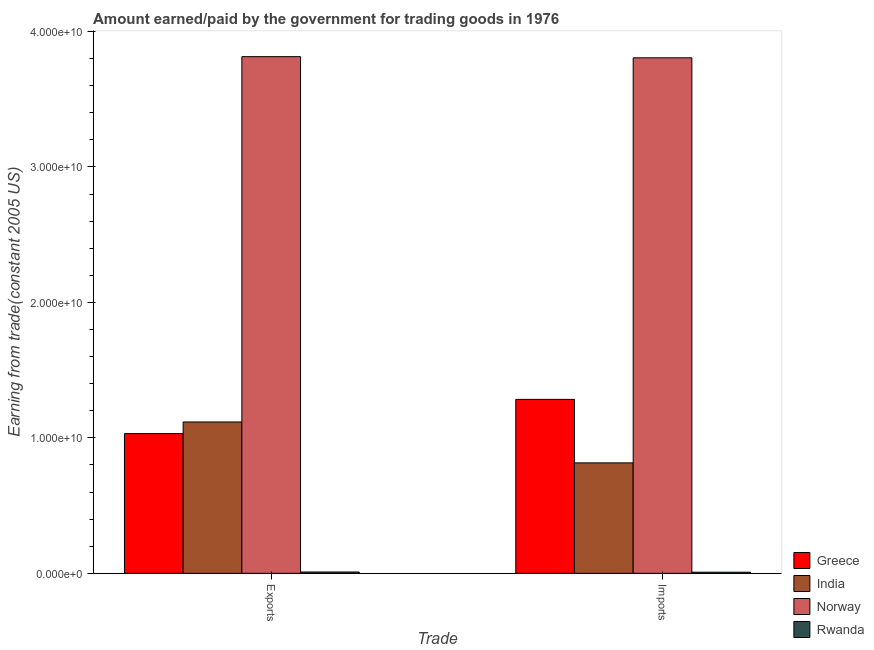How many different coloured bars are there?
Keep it short and to the point. 4. Are the number of bars per tick equal to the number of legend labels?
Provide a succinct answer. Yes. What is the label of the 2nd group of bars from the left?
Offer a very short reply. Imports. What is the amount paid for imports in Norway?
Keep it short and to the point. 3.81e+1. Across all countries, what is the maximum amount earned from exports?
Give a very brief answer. 3.81e+1. Across all countries, what is the minimum amount earned from exports?
Your response must be concise. 9.77e+07. In which country was the amount paid for imports maximum?
Your answer should be very brief. Norway. In which country was the amount earned from exports minimum?
Offer a terse response. Rwanda. What is the total amount earned from exports in the graph?
Your answer should be very brief. 5.97e+1. What is the difference between the amount earned from exports in India and that in Rwanda?
Offer a very short reply. 1.11e+1. What is the difference between the amount paid for imports in Norway and the amount earned from exports in India?
Your answer should be very brief. 2.69e+1. What is the average amount earned from exports per country?
Offer a very short reply. 1.49e+1. What is the difference between the amount paid for imports and amount earned from exports in India?
Make the answer very short. -3.02e+09. In how many countries, is the amount paid for imports greater than 38000000000 US$?
Provide a succinct answer. 1. What is the ratio of the amount earned from exports in Norway to that in Rwanda?
Your answer should be compact. 390.39. Is the amount paid for imports in Greece less than that in India?
Make the answer very short. No. In how many countries, is the amount paid for imports greater than the average amount paid for imports taken over all countries?
Provide a succinct answer. 1. How many bars are there?
Make the answer very short. 8. Are all the bars in the graph horizontal?
Offer a very short reply. No. How many countries are there in the graph?
Your answer should be very brief. 4. What is the difference between two consecutive major ticks on the Y-axis?
Provide a succinct answer. 1.00e+1. Are the values on the major ticks of Y-axis written in scientific E-notation?
Your response must be concise. Yes. Does the graph contain any zero values?
Offer a terse response. No. Does the graph contain grids?
Offer a terse response. No. How are the legend labels stacked?
Offer a terse response. Vertical. What is the title of the graph?
Provide a succinct answer. Amount earned/paid by the government for trading goods in 1976. Does "New Caledonia" appear as one of the legend labels in the graph?
Offer a very short reply. No. What is the label or title of the X-axis?
Keep it short and to the point. Trade. What is the label or title of the Y-axis?
Make the answer very short. Earning from trade(constant 2005 US). What is the Earning from trade(constant 2005 US) of Greece in Exports?
Give a very brief answer. 1.03e+1. What is the Earning from trade(constant 2005 US) in India in Exports?
Your answer should be compact. 1.12e+1. What is the Earning from trade(constant 2005 US) in Norway in Exports?
Offer a very short reply. 3.81e+1. What is the Earning from trade(constant 2005 US) in Rwanda in Exports?
Your response must be concise. 9.77e+07. What is the Earning from trade(constant 2005 US) in Greece in Imports?
Provide a succinct answer. 1.28e+1. What is the Earning from trade(constant 2005 US) in India in Imports?
Offer a terse response. 8.15e+09. What is the Earning from trade(constant 2005 US) in Norway in Imports?
Provide a short and direct response. 3.81e+1. What is the Earning from trade(constant 2005 US) of Rwanda in Imports?
Provide a succinct answer. 8.24e+07. Across all Trade, what is the maximum Earning from trade(constant 2005 US) in Greece?
Keep it short and to the point. 1.28e+1. Across all Trade, what is the maximum Earning from trade(constant 2005 US) of India?
Provide a short and direct response. 1.12e+1. Across all Trade, what is the maximum Earning from trade(constant 2005 US) in Norway?
Give a very brief answer. 3.81e+1. Across all Trade, what is the maximum Earning from trade(constant 2005 US) of Rwanda?
Give a very brief answer. 9.77e+07. Across all Trade, what is the minimum Earning from trade(constant 2005 US) in Greece?
Ensure brevity in your answer.  1.03e+1. Across all Trade, what is the minimum Earning from trade(constant 2005 US) of India?
Offer a very short reply. 8.15e+09. Across all Trade, what is the minimum Earning from trade(constant 2005 US) in Norway?
Make the answer very short. 3.81e+1. Across all Trade, what is the minimum Earning from trade(constant 2005 US) in Rwanda?
Your answer should be compact. 8.24e+07. What is the total Earning from trade(constant 2005 US) in Greece in the graph?
Make the answer very short. 2.32e+1. What is the total Earning from trade(constant 2005 US) in India in the graph?
Give a very brief answer. 1.93e+1. What is the total Earning from trade(constant 2005 US) in Norway in the graph?
Your answer should be compact. 7.62e+1. What is the total Earning from trade(constant 2005 US) in Rwanda in the graph?
Provide a short and direct response. 1.80e+08. What is the difference between the Earning from trade(constant 2005 US) of Greece in Exports and that in Imports?
Offer a terse response. -2.53e+09. What is the difference between the Earning from trade(constant 2005 US) in India in Exports and that in Imports?
Your response must be concise. 3.02e+09. What is the difference between the Earning from trade(constant 2005 US) of Norway in Exports and that in Imports?
Keep it short and to the point. 8.51e+07. What is the difference between the Earning from trade(constant 2005 US) of Rwanda in Exports and that in Imports?
Keep it short and to the point. 1.53e+07. What is the difference between the Earning from trade(constant 2005 US) in Greece in Exports and the Earning from trade(constant 2005 US) in India in Imports?
Your answer should be very brief. 2.16e+09. What is the difference between the Earning from trade(constant 2005 US) in Greece in Exports and the Earning from trade(constant 2005 US) in Norway in Imports?
Give a very brief answer. -2.77e+1. What is the difference between the Earning from trade(constant 2005 US) in Greece in Exports and the Earning from trade(constant 2005 US) in Rwanda in Imports?
Your answer should be compact. 1.02e+1. What is the difference between the Earning from trade(constant 2005 US) of India in Exports and the Earning from trade(constant 2005 US) of Norway in Imports?
Your answer should be very brief. -2.69e+1. What is the difference between the Earning from trade(constant 2005 US) of India in Exports and the Earning from trade(constant 2005 US) of Rwanda in Imports?
Offer a terse response. 1.11e+1. What is the difference between the Earning from trade(constant 2005 US) in Norway in Exports and the Earning from trade(constant 2005 US) in Rwanda in Imports?
Your answer should be compact. 3.81e+1. What is the average Earning from trade(constant 2005 US) in Greece per Trade?
Offer a terse response. 1.16e+1. What is the average Earning from trade(constant 2005 US) in India per Trade?
Keep it short and to the point. 9.66e+09. What is the average Earning from trade(constant 2005 US) of Norway per Trade?
Provide a short and direct response. 3.81e+1. What is the average Earning from trade(constant 2005 US) of Rwanda per Trade?
Your answer should be compact. 9.00e+07. What is the difference between the Earning from trade(constant 2005 US) of Greece and Earning from trade(constant 2005 US) of India in Exports?
Keep it short and to the point. -8.59e+08. What is the difference between the Earning from trade(constant 2005 US) of Greece and Earning from trade(constant 2005 US) of Norway in Exports?
Offer a very short reply. -2.78e+1. What is the difference between the Earning from trade(constant 2005 US) of Greece and Earning from trade(constant 2005 US) of Rwanda in Exports?
Keep it short and to the point. 1.02e+1. What is the difference between the Earning from trade(constant 2005 US) of India and Earning from trade(constant 2005 US) of Norway in Exports?
Give a very brief answer. -2.70e+1. What is the difference between the Earning from trade(constant 2005 US) in India and Earning from trade(constant 2005 US) in Rwanda in Exports?
Your response must be concise. 1.11e+1. What is the difference between the Earning from trade(constant 2005 US) of Norway and Earning from trade(constant 2005 US) of Rwanda in Exports?
Provide a short and direct response. 3.80e+1. What is the difference between the Earning from trade(constant 2005 US) of Greece and Earning from trade(constant 2005 US) of India in Imports?
Give a very brief answer. 4.69e+09. What is the difference between the Earning from trade(constant 2005 US) of Greece and Earning from trade(constant 2005 US) of Norway in Imports?
Offer a terse response. -2.52e+1. What is the difference between the Earning from trade(constant 2005 US) of Greece and Earning from trade(constant 2005 US) of Rwanda in Imports?
Keep it short and to the point. 1.28e+1. What is the difference between the Earning from trade(constant 2005 US) in India and Earning from trade(constant 2005 US) in Norway in Imports?
Provide a short and direct response. -2.99e+1. What is the difference between the Earning from trade(constant 2005 US) of India and Earning from trade(constant 2005 US) of Rwanda in Imports?
Keep it short and to the point. 8.07e+09. What is the difference between the Earning from trade(constant 2005 US) in Norway and Earning from trade(constant 2005 US) in Rwanda in Imports?
Provide a succinct answer. 3.80e+1. What is the ratio of the Earning from trade(constant 2005 US) in Greece in Exports to that in Imports?
Give a very brief answer. 0.8. What is the ratio of the Earning from trade(constant 2005 US) of India in Exports to that in Imports?
Your response must be concise. 1.37. What is the ratio of the Earning from trade(constant 2005 US) in Norway in Exports to that in Imports?
Offer a very short reply. 1. What is the ratio of the Earning from trade(constant 2005 US) of Rwanda in Exports to that in Imports?
Offer a very short reply. 1.19. What is the difference between the highest and the second highest Earning from trade(constant 2005 US) of Greece?
Your answer should be compact. 2.53e+09. What is the difference between the highest and the second highest Earning from trade(constant 2005 US) of India?
Make the answer very short. 3.02e+09. What is the difference between the highest and the second highest Earning from trade(constant 2005 US) in Norway?
Keep it short and to the point. 8.51e+07. What is the difference between the highest and the second highest Earning from trade(constant 2005 US) in Rwanda?
Your answer should be compact. 1.53e+07. What is the difference between the highest and the lowest Earning from trade(constant 2005 US) in Greece?
Your answer should be very brief. 2.53e+09. What is the difference between the highest and the lowest Earning from trade(constant 2005 US) in India?
Offer a very short reply. 3.02e+09. What is the difference between the highest and the lowest Earning from trade(constant 2005 US) of Norway?
Give a very brief answer. 8.51e+07. What is the difference between the highest and the lowest Earning from trade(constant 2005 US) in Rwanda?
Keep it short and to the point. 1.53e+07. 